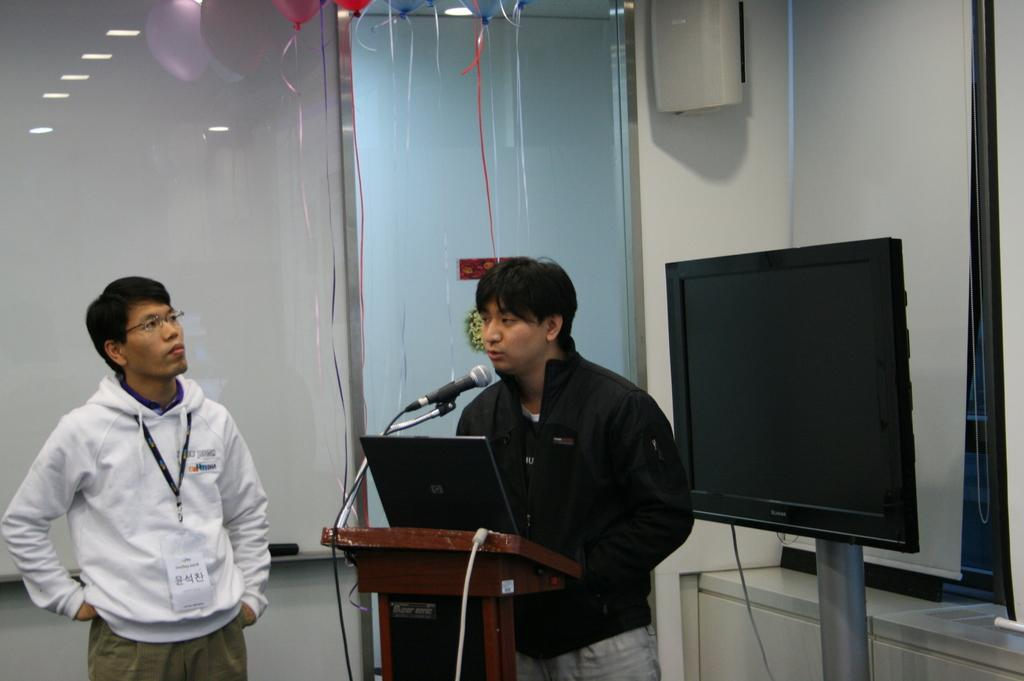How many people are present in the image? There are two people in the image. What type of equipment can be seen in the image? There are monitors and a mic visible in the image. What is the main object in the foreground of the image? There is a podium in the image. What can be seen in the background of the image? There is a wall and objects visible in the background of the image. Are there any cobwebs visible on the wall in the background of the image? There is no mention of cobwebs in the provided facts, so we cannot determine if any are present in the image. Can you see a tiger in the image? There is no mention of a tiger in the provided facts, so we cannot determine if one is present in the image. 